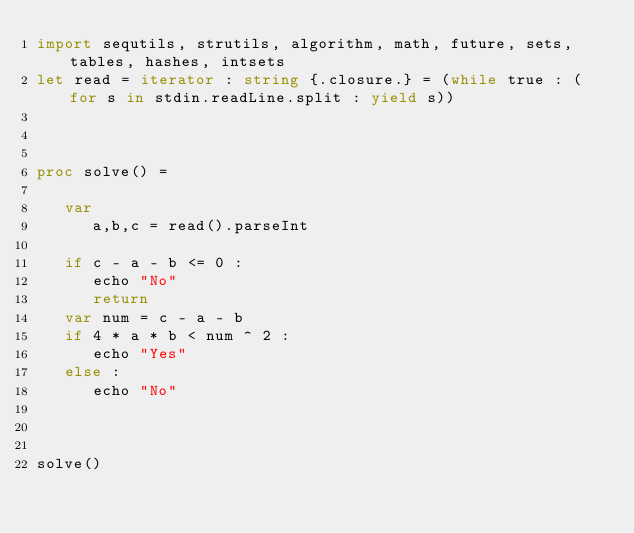<code> <loc_0><loc_0><loc_500><loc_500><_Nim_>import sequtils, strutils, algorithm, math, future, sets, tables, hashes, intsets
let read = iterator : string {.closure.} = (while true : (for s in stdin.readLine.split : yield s))



proc solve() =
   
   var
      a,b,c = read().parseInt

   if c - a - b <= 0 : 
      echo "No"
      return
   var num = c - a - b
   if 4 * a * b < num ^ 2 : 
      echo "Yes"
   else : 
      echo "No"
      
   

solve()
</code> 